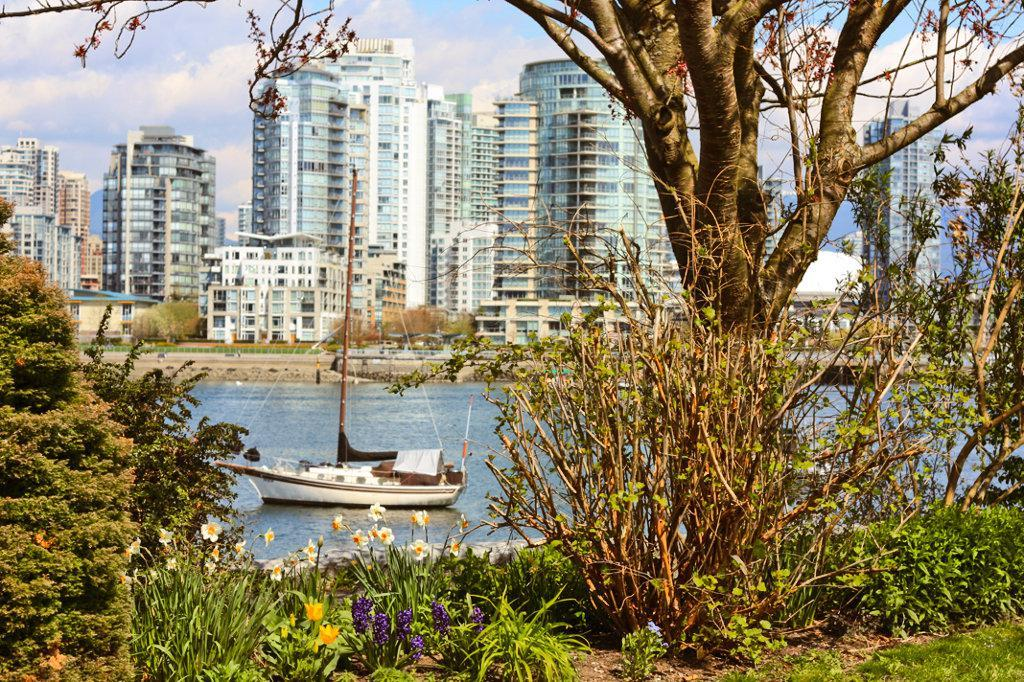What type of plants can be seen in the image? There are flowers and trees in the image. What is located on the water in the image? There is a boat on the water in the image. What can be seen in the background of the image? There are buildings and clouds visible in the background of the image. How many beds can be seen in the image? There are no beds present in the image. What type of material is the boat made of in the image? The provided facts do not mention the material of the boat, so it cannot be determined from the image. 